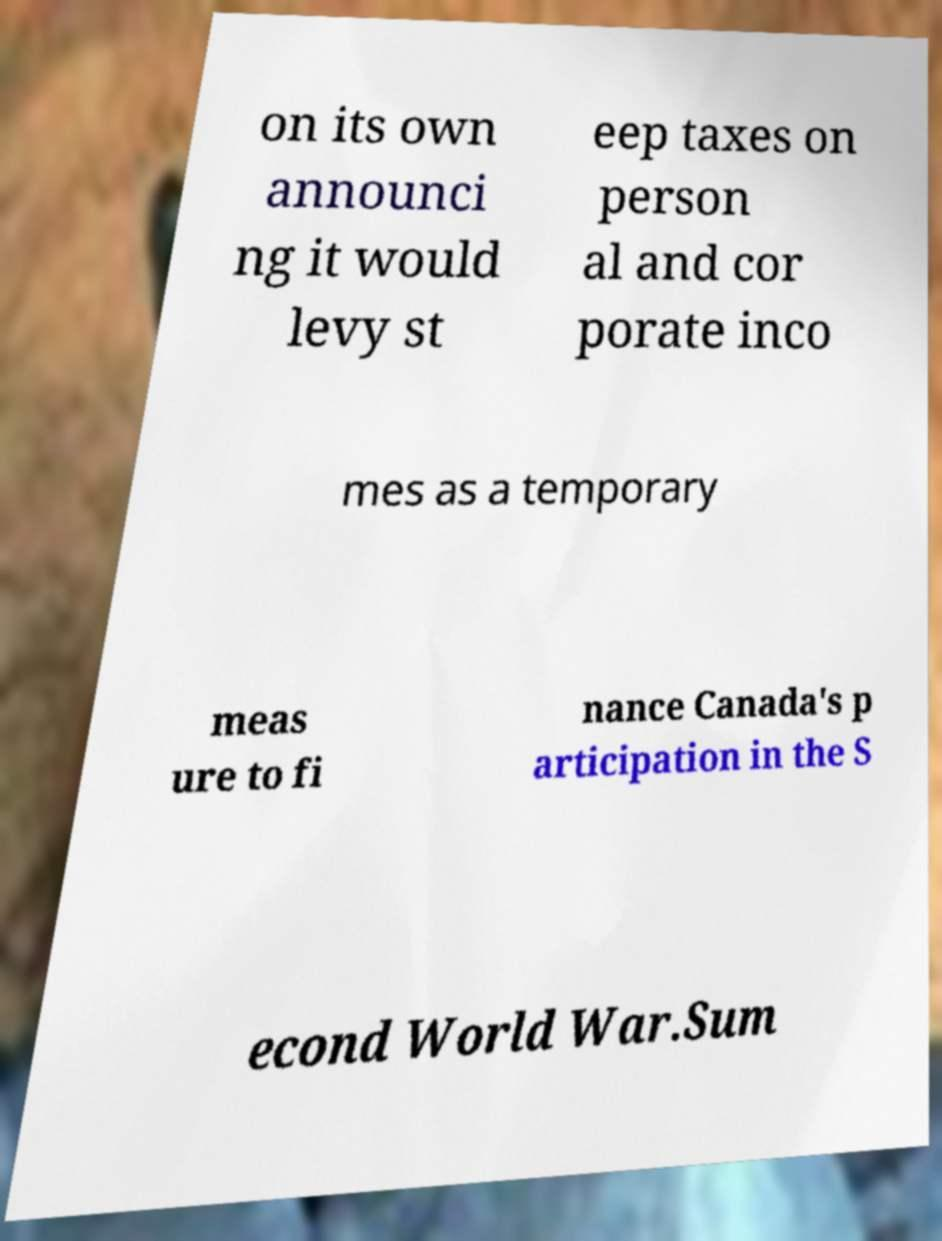What messages or text are displayed in this image? I need them in a readable, typed format. on its own announci ng it would levy st eep taxes on person al and cor porate inco mes as a temporary meas ure to fi nance Canada's p articipation in the S econd World War.Sum 